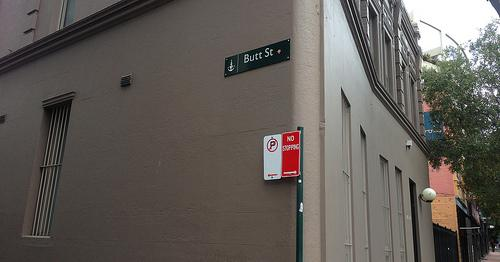Question: what street name is on the sign?
Choices:
A. Finger.
B. Butt.
C. Hand.
D. Leg.
Answer with the letter. Answer: B Question: how many cars can park here?
Choices:
A. Zero.
B. One.
C. Two.
D. Three.
Answer with the letter. Answer: A Question: what does the white sign mean?
Choices:
A. Go slow.
B. No parking.
C. Keep Moving.
D. Keep right.
Answer with the letter. Answer: B Question: what side of the building has more windows?
Choices:
A. Right.
B. Left.
C. Top.
D. Bottom.
Answer with the letter. Answer: A Question: how many people are in the picture?
Choices:
A. One.
B. None.
C. Two.
D. Three.
Answer with the letter. Answer: B 